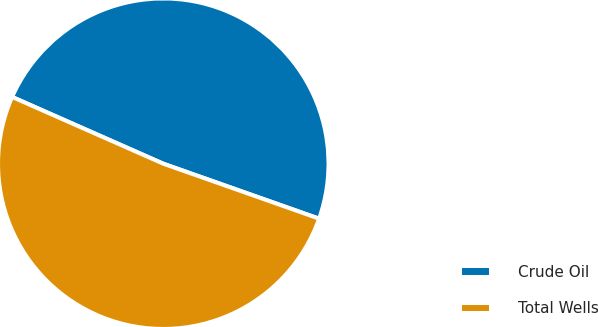<chart> <loc_0><loc_0><loc_500><loc_500><pie_chart><fcel>Crude Oil<fcel>Total Wells<nl><fcel>48.78%<fcel>51.22%<nl></chart> 